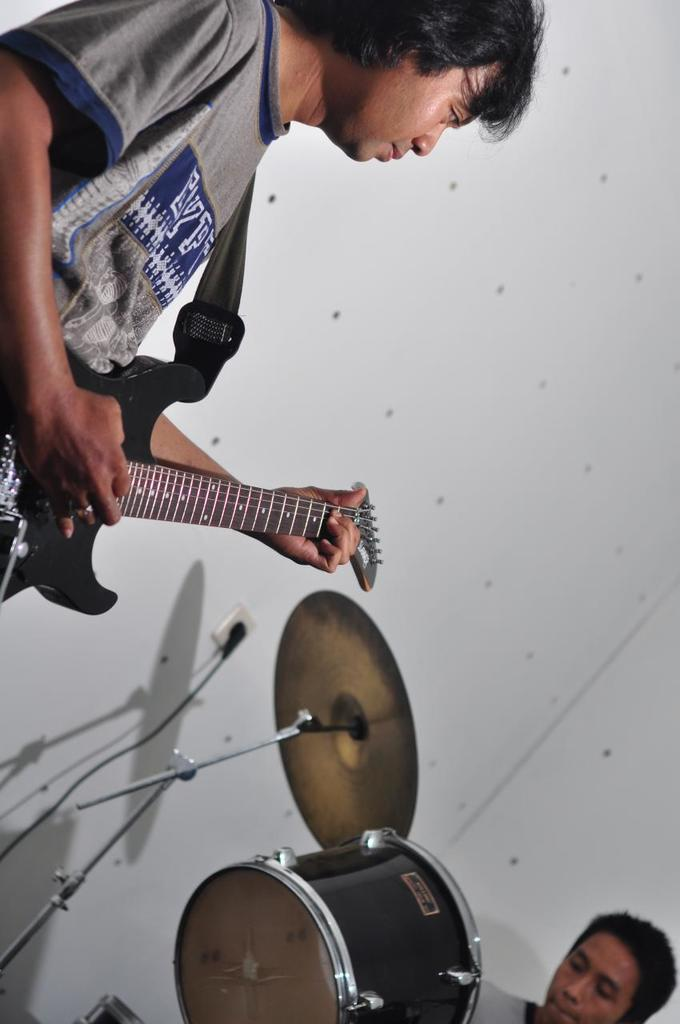What is the man in the image doing? There is a man in the image playing a guitar. Are there any other musicians in the image? Yes, there is another man in the image playing drums. What can be seen in the background of the image? There is a wall in the background of the image. How many crates are being used by the musicians in the image? There are no crates visible in the image; the musicians are playing a guitar and drums. Can you describe the bee's role in the musical performance in the image? There are no bees present in the image; it features two musicians playing instruments. 